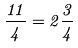Convert formula to latex. <formula><loc_0><loc_0><loc_500><loc_500>\frac { 1 1 } { 4 } = 2 \frac { 3 } { 4 }</formula> 